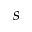Convert formula to latex. <formula><loc_0><loc_0><loc_500><loc_500>s</formula> 